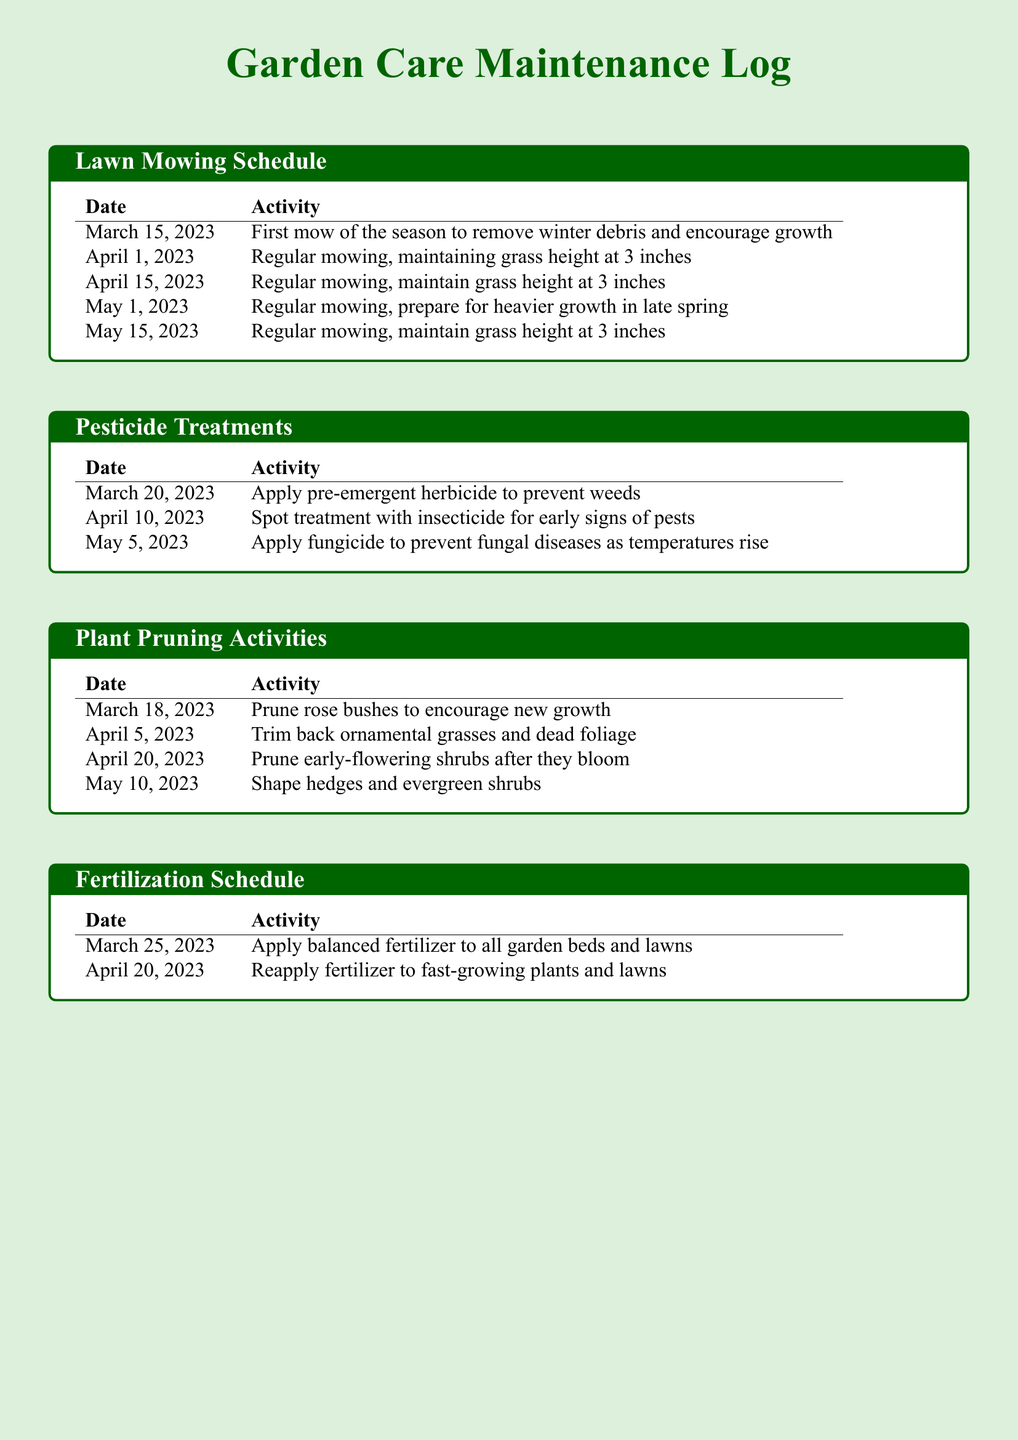what date was the first mow of the season? The first mow of the season occurred on March 15, 2023, as listed in the lawn mowing schedule.
Answer: March 15, 2023 how many pesticide treatments were applied? The document lists three pesticide treatments under the pesticide treatments section.
Answer: 3 when were the rose bushes pruned? The pruning of rose bushes took place on March 18, 2023, as detailed in the plant pruning activities section.
Answer: March 18, 2023 what is the grass height maintained during regular mowing? The document states that the grass height is maintained at 3 inches during regular mowing activities.
Answer: 3 inches which activity was performed on April 20, 2023? On April 20, 2023, early-flowering shrubs were pruned after blooming, as noted in the plant pruning activities section.
Answer: Prune early-flowering shrubs what type of herbicide was applied on March 20, 2023? A pre-emergent herbicide was applied on March 20, 2023, to prevent weeds, as mentioned in the pesticide treatments section.
Answer: Pre-emergent herbicide how many times was fertilizer applied? The document shows that fertilizer was applied twice according to the fertilization schedule.
Answer: 2 times what is the main purpose of the first mow of the season? The first mow of the season was intended to remove winter debris and encourage growth, as indicated in the lawn mowing schedule.
Answer: Remove winter debris and encourage growth 